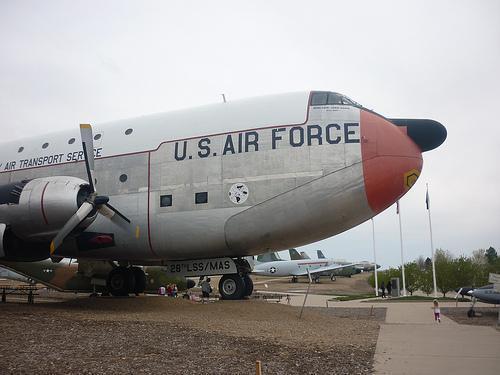How many planes are in the picture?
Give a very brief answer. 5. 